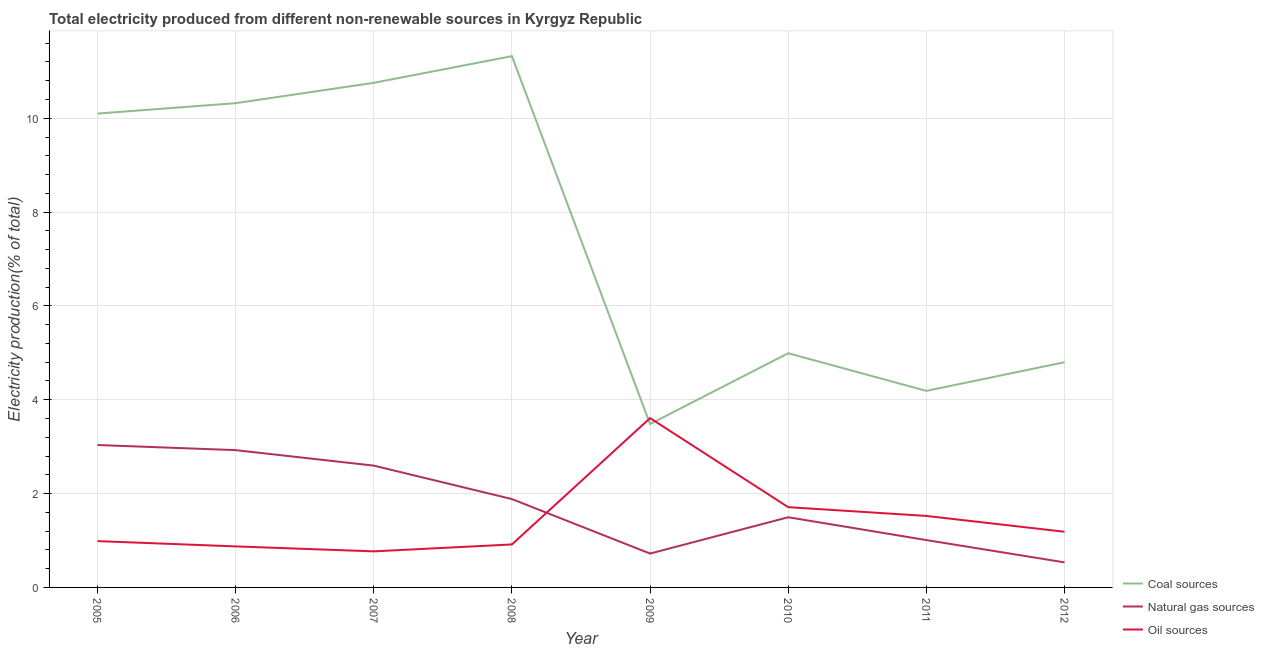Does the line corresponding to percentage of electricity produced by coal intersect with the line corresponding to percentage of electricity produced by natural gas?
Your answer should be compact. No. What is the percentage of electricity produced by natural gas in 2009?
Your answer should be compact. 0.72. Across all years, what is the maximum percentage of electricity produced by oil sources?
Ensure brevity in your answer.  3.61. Across all years, what is the minimum percentage of electricity produced by oil sources?
Offer a terse response. 0.77. What is the total percentage of electricity produced by coal in the graph?
Provide a short and direct response. 59.96. What is the difference between the percentage of electricity produced by oil sources in 2010 and that in 2011?
Keep it short and to the point. 0.19. What is the difference between the percentage of electricity produced by oil sources in 2008 and the percentage of electricity produced by natural gas in 2006?
Provide a succinct answer. -2.01. What is the average percentage of electricity produced by oil sources per year?
Make the answer very short. 1.45. In the year 2010, what is the difference between the percentage of electricity produced by oil sources and percentage of electricity produced by natural gas?
Offer a terse response. 0.21. In how many years, is the percentage of electricity produced by oil sources greater than 7.6 %?
Offer a terse response. 0. What is the ratio of the percentage of electricity produced by natural gas in 2005 to that in 2011?
Ensure brevity in your answer.  3.01. Is the difference between the percentage of electricity produced by natural gas in 2010 and 2011 greater than the difference between the percentage of electricity produced by coal in 2010 and 2011?
Ensure brevity in your answer.  No. What is the difference between the highest and the second highest percentage of electricity produced by oil sources?
Your response must be concise. 1.9. What is the difference between the highest and the lowest percentage of electricity produced by natural gas?
Provide a short and direct response. 2.5. Is the sum of the percentage of electricity produced by oil sources in 2005 and 2007 greater than the maximum percentage of electricity produced by natural gas across all years?
Your response must be concise. No. Does the percentage of electricity produced by oil sources monotonically increase over the years?
Keep it short and to the point. No. What is the difference between two consecutive major ticks on the Y-axis?
Your answer should be very brief. 2. Are the values on the major ticks of Y-axis written in scientific E-notation?
Your response must be concise. No. Does the graph contain grids?
Offer a terse response. Yes. Where does the legend appear in the graph?
Offer a terse response. Bottom right. How many legend labels are there?
Ensure brevity in your answer.  3. How are the legend labels stacked?
Offer a terse response. Vertical. What is the title of the graph?
Offer a very short reply. Total electricity produced from different non-renewable sources in Kyrgyz Republic. Does "Negligence towards kids" appear as one of the legend labels in the graph?
Provide a succinct answer. No. What is the label or title of the X-axis?
Offer a terse response. Year. What is the Electricity production(% of total) in Coal sources in 2005?
Ensure brevity in your answer.  10.1. What is the Electricity production(% of total) in Natural gas sources in 2005?
Your answer should be compact. 3.04. What is the Electricity production(% of total) in Oil sources in 2005?
Keep it short and to the point. 0.99. What is the Electricity production(% of total) of Coal sources in 2006?
Your response must be concise. 10.32. What is the Electricity production(% of total) in Natural gas sources in 2006?
Keep it short and to the point. 2.93. What is the Electricity production(% of total) of Oil sources in 2006?
Provide a succinct answer. 0.87. What is the Electricity production(% of total) of Coal sources in 2007?
Your answer should be compact. 10.76. What is the Electricity production(% of total) in Natural gas sources in 2007?
Give a very brief answer. 2.6. What is the Electricity production(% of total) of Oil sources in 2007?
Give a very brief answer. 0.77. What is the Electricity production(% of total) of Coal sources in 2008?
Provide a short and direct response. 11.32. What is the Electricity production(% of total) of Natural gas sources in 2008?
Give a very brief answer. 1.88. What is the Electricity production(% of total) of Oil sources in 2008?
Keep it short and to the point. 0.92. What is the Electricity production(% of total) of Coal sources in 2009?
Provide a short and direct response. 3.48. What is the Electricity production(% of total) of Natural gas sources in 2009?
Provide a succinct answer. 0.72. What is the Electricity production(% of total) of Oil sources in 2009?
Provide a succinct answer. 3.61. What is the Electricity production(% of total) in Coal sources in 2010?
Provide a short and direct response. 4.99. What is the Electricity production(% of total) in Natural gas sources in 2010?
Your answer should be compact. 1.5. What is the Electricity production(% of total) of Oil sources in 2010?
Ensure brevity in your answer.  1.71. What is the Electricity production(% of total) of Coal sources in 2011?
Your response must be concise. 4.19. What is the Electricity production(% of total) in Natural gas sources in 2011?
Give a very brief answer. 1.01. What is the Electricity production(% of total) in Oil sources in 2011?
Your answer should be very brief. 1.52. What is the Electricity production(% of total) of Coal sources in 2012?
Provide a succinct answer. 4.8. What is the Electricity production(% of total) in Natural gas sources in 2012?
Make the answer very short. 0.53. What is the Electricity production(% of total) in Oil sources in 2012?
Ensure brevity in your answer.  1.19. Across all years, what is the maximum Electricity production(% of total) in Coal sources?
Give a very brief answer. 11.32. Across all years, what is the maximum Electricity production(% of total) of Natural gas sources?
Your answer should be compact. 3.04. Across all years, what is the maximum Electricity production(% of total) in Oil sources?
Your response must be concise. 3.61. Across all years, what is the minimum Electricity production(% of total) of Coal sources?
Your response must be concise. 3.48. Across all years, what is the minimum Electricity production(% of total) of Natural gas sources?
Keep it short and to the point. 0.53. Across all years, what is the minimum Electricity production(% of total) of Oil sources?
Offer a very short reply. 0.77. What is the total Electricity production(% of total) in Coal sources in the graph?
Ensure brevity in your answer.  59.96. What is the total Electricity production(% of total) of Natural gas sources in the graph?
Give a very brief answer. 14.2. What is the total Electricity production(% of total) in Oil sources in the graph?
Offer a terse response. 11.58. What is the difference between the Electricity production(% of total) of Coal sources in 2005 and that in 2006?
Ensure brevity in your answer.  -0.22. What is the difference between the Electricity production(% of total) of Natural gas sources in 2005 and that in 2006?
Provide a succinct answer. 0.11. What is the difference between the Electricity production(% of total) in Oil sources in 2005 and that in 2006?
Keep it short and to the point. 0.11. What is the difference between the Electricity production(% of total) in Coal sources in 2005 and that in 2007?
Ensure brevity in your answer.  -0.66. What is the difference between the Electricity production(% of total) of Natural gas sources in 2005 and that in 2007?
Provide a short and direct response. 0.44. What is the difference between the Electricity production(% of total) in Oil sources in 2005 and that in 2007?
Make the answer very short. 0.22. What is the difference between the Electricity production(% of total) in Coal sources in 2005 and that in 2008?
Your answer should be very brief. -1.22. What is the difference between the Electricity production(% of total) of Natural gas sources in 2005 and that in 2008?
Provide a succinct answer. 1.15. What is the difference between the Electricity production(% of total) in Oil sources in 2005 and that in 2008?
Your answer should be very brief. 0.07. What is the difference between the Electricity production(% of total) of Coal sources in 2005 and that in 2009?
Your answer should be compact. 6.62. What is the difference between the Electricity production(% of total) of Natural gas sources in 2005 and that in 2009?
Make the answer very short. 2.31. What is the difference between the Electricity production(% of total) of Oil sources in 2005 and that in 2009?
Keep it short and to the point. -2.62. What is the difference between the Electricity production(% of total) in Coal sources in 2005 and that in 2010?
Keep it short and to the point. 5.11. What is the difference between the Electricity production(% of total) in Natural gas sources in 2005 and that in 2010?
Provide a succinct answer. 1.54. What is the difference between the Electricity production(% of total) of Oil sources in 2005 and that in 2010?
Your answer should be very brief. -0.72. What is the difference between the Electricity production(% of total) of Coal sources in 2005 and that in 2011?
Provide a succinct answer. 5.91. What is the difference between the Electricity production(% of total) of Natural gas sources in 2005 and that in 2011?
Make the answer very short. 2.03. What is the difference between the Electricity production(% of total) of Oil sources in 2005 and that in 2011?
Your answer should be very brief. -0.54. What is the difference between the Electricity production(% of total) in Coal sources in 2005 and that in 2012?
Offer a terse response. 5.3. What is the difference between the Electricity production(% of total) in Natural gas sources in 2005 and that in 2012?
Offer a very short reply. 2.5. What is the difference between the Electricity production(% of total) of Oil sources in 2005 and that in 2012?
Offer a terse response. -0.2. What is the difference between the Electricity production(% of total) in Coal sources in 2006 and that in 2007?
Your response must be concise. -0.43. What is the difference between the Electricity production(% of total) in Natural gas sources in 2006 and that in 2007?
Your answer should be compact. 0.33. What is the difference between the Electricity production(% of total) of Oil sources in 2006 and that in 2007?
Give a very brief answer. 0.11. What is the difference between the Electricity production(% of total) in Coal sources in 2006 and that in 2008?
Give a very brief answer. -1. What is the difference between the Electricity production(% of total) of Natural gas sources in 2006 and that in 2008?
Provide a succinct answer. 1.04. What is the difference between the Electricity production(% of total) in Oil sources in 2006 and that in 2008?
Keep it short and to the point. -0.04. What is the difference between the Electricity production(% of total) of Coal sources in 2006 and that in 2009?
Your answer should be very brief. 6.84. What is the difference between the Electricity production(% of total) in Natural gas sources in 2006 and that in 2009?
Make the answer very short. 2.2. What is the difference between the Electricity production(% of total) in Oil sources in 2006 and that in 2009?
Provide a short and direct response. -2.73. What is the difference between the Electricity production(% of total) in Coal sources in 2006 and that in 2010?
Provide a succinct answer. 5.33. What is the difference between the Electricity production(% of total) in Natural gas sources in 2006 and that in 2010?
Provide a short and direct response. 1.43. What is the difference between the Electricity production(% of total) of Oil sources in 2006 and that in 2010?
Provide a short and direct response. -0.84. What is the difference between the Electricity production(% of total) in Coal sources in 2006 and that in 2011?
Offer a terse response. 6.13. What is the difference between the Electricity production(% of total) in Natural gas sources in 2006 and that in 2011?
Give a very brief answer. 1.92. What is the difference between the Electricity production(% of total) of Oil sources in 2006 and that in 2011?
Make the answer very short. -0.65. What is the difference between the Electricity production(% of total) of Coal sources in 2006 and that in 2012?
Your answer should be compact. 5.52. What is the difference between the Electricity production(% of total) of Natural gas sources in 2006 and that in 2012?
Provide a short and direct response. 2.39. What is the difference between the Electricity production(% of total) in Oil sources in 2006 and that in 2012?
Your answer should be very brief. -0.31. What is the difference between the Electricity production(% of total) in Coal sources in 2007 and that in 2008?
Your response must be concise. -0.57. What is the difference between the Electricity production(% of total) of Natural gas sources in 2007 and that in 2008?
Give a very brief answer. 0.71. What is the difference between the Electricity production(% of total) of Oil sources in 2007 and that in 2008?
Your answer should be compact. -0.15. What is the difference between the Electricity production(% of total) in Coal sources in 2007 and that in 2009?
Provide a succinct answer. 7.27. What is the difference between the Electricity production(% of total) of Natural gas sources in 2007 and that in 2009?
Keep it short and to the point. 1.87. What is the difference between the Electricity production(% of total) in Oil sources in 2007 and that in 2009?
Provide a succinct answer. -2.84. What is the difference between the Electricity production(% of total) in Coal sources in 2007 and that in 2010?
Provide a short and direct response. 5.76. What is the difference between the Electricity production(% of total) of Natural gas sources in 2007 and that in 2010?
Give a very brief answer. 1.1. What is the difference between the Electricity production(% of total) in Oil sources in 2007 and that in 2010?
Your answer should be compact. -0.94. What is the difference between the Electricity production(% of total) in Coal sources in 2007 and that in 2011?
Keep it short and to the point. 6.57. What is the difference between the Electricity production(% of total) in Natural gas sources in 2007 and that in 2011?
Ensure brevity in your answer.  1.59. What is the difference between the Electricity production(% of total) in Oil sources in 2007 and that in 2011?
Your answer should be very brief. -0.76. What is the difference between the Electricity production(% of total) of Coal sources in 2007 and that in 2012?
Your answer should be very brief. 5.96. What is the difference between the Electricity production(% of total) in Natural gas sources in 2007 and that in 2012?
Offer a terse response. 2.06. What is the difference between the Electricity production(% of total) of Oil sources in 2007 and that in 2012?
Give a very brief answer. -0.42. What is the difference between the Electricity production(% of total) in Coal sources in 2008 and that in 2009?
Make the answer very short. 7.84. What is the difference between the Electricity production(% of total) of Natural gas sources in 2008 and that in 2009?
Your answer should be compact. 1.16. What is the difference between the Electricity production(% of total) in Oil sources in 2008 and that in 2009?
Your answer should be compact. -2.69. What is the difference between the Electricity production(% of total) in Coal sources in 2008 and that in 2010?
Give a very brief answer. 6.33. What is the difference between the Electricity production(% of total) in Natural gas sources in 2008 and that in 2010?
Provide a succinct answer. 0.39. What is the difference between the Electricity production(% of total) in Oil sources in 2008 and that in 2010?
Offer a very short reply. -0.79. What is the difference between the Electricity production(% of total) in Coal sources in 2008 and that in 2011?
Keep it short and to the point. 7.13. What is the difference between the Electricity production(% of total) in Natural gas sources in 2008 and that in 2011?
Your answer should be compact. 0.87. What is the difference between the Electricity production(% of total) of Oil sources in 2008 and that in 2011?
Provide a short and direct response. -0.61. What is the difference between the Electricity production(% of total) of Coal sources in 2008 and that in 2012?
Make the answer very short. 6.52. What is the difference between the Electricity production(% of total) of Natural gas sources in 2008 and that in 2012?
Provide a succinct answer. 1.35. What is the difference between the Electricity production(% of total) of Oil sources in 2008 and that in 2012?
Make the answer very short. -0.27. What is the difference between the Electricity production(% of total) in Coal sources in 2009 and that in 2010?
Ensure brevity in your answer.  -1.51. What is the difference between the Electricity production(% of total) of Natural gas sources in 2009 and that in 2010?
Your answer should be very brief. -0.77. What is the difference between the Electricity production(% of total) of Oil sources in 2009 and that in 2010?
Offer a terse response. 1.9. What is the difference between the Electricity production(% of total) of Coal sources in 2009 and that in 2011?
Provide a short and direct response. -0.71. What is the difference between the Electricity production(% of total) of Natural gas sources in 2009 and that in 2011?
Provide a succinct answer. -0.29. What is the difference between the Electricity production(% of total) in Oil sources in 2009 and that in 2011?
Make the answer very short. 2.09. What is the difference between the Electricity production(% of total) in Coal sources in 2009 and that in 2012?
Provide a succinct answer. -1.32. What is the difference between the Electricity production(% of total) of Natural gas sources in 2009 and that in 2012?
Offer a terse response. 0.19. What is the difference between the Electricity production(% of total) in Oil sources in 2009 and that in 2012?
Your answer should be compact. 2.42. What is the difference between the Electricity production(% of total) in Coal sources in 2010 and that in 2011?
Ensure brevity in your answer.  0.8. What is the difference between the Electricity production(% of total) of Natural gas sources in 2010 and that in 2011?
Provide a succinct answer. 0.49. What is the difference between the Electricity production(% of total) of Oil sources in 2010 and that in 2011?
Offer a terse response. 0.19. What is the difference between the Electricity production(% of total) of Coal sources in 2010 and that in 2012?
Ensure brevity in your answer.  0.19. What is the difference between the Electricity production(% of total) of Natural gas sources in 2010 and that in 2012?
Provide a succinct answer. 0.96. What is the difference between the Electricity production(% of total) of Oil sources in 2010 and that in 2012?
Make the answer very short. 0.52. What is the difference between the Electricity production(% of total) of Coal sources in 2011 and that in 2012?
Ensure brevity in your answer.  -0.61. What is the difference between the Electricity production(% of total) in Natural gas sources in 2011 and that in 2012?
Your answer should be compact. 0.48. What is the difference between the Electricity production(% of total) of Oil sources in 2011 and that in 2012?
Make the answer very short. 0.34. What is the difference between the Electricity production(% of total) of Coal sources in 2005 and the Electricity production(% of total) of Natural gas sources in 2006?
Ensure brevity in your answer.  7.17. What is the difference between the Electricity production(% of total) of Coal sources in 2005 and the Electricity production(% of total) of Oil sources in 2006?
Your answer should be very brief. 9.23. What is the difference between the Electricity production(% of total) of Natural gas sources in 2005 and the Electricity production(% of total) of Oil sources in 2006?
Give a very brief answer. 2.16. What is the difference between the Electricity production(% of total) in Coal sources in 2005 and the Electricity production(% of total) in Natural gas sources in 2007?
Offer a terse response. 7.5. What is the difference between the Electricity production(% of total) of Coal sources in 2005 and the Electricity production(% of total) of Oil sources in 2007?
Give a very brief answer. 9.33. What is the difference between the Electricity production(% of total) of Natural gas sources in 2005 and the Electricity production(% of total) of Oil sources in 2007?
Offer a terse response. 2.27. What is the difference between the Electricity production(% of total) of Coal sources in 2005 and the Electricity production(% of total) of Natural gas sources in 2008?
Your response must be concise. 8.22. What is the difference between the Electricity production(% of total) in Coal sources in 2005 and the Electricity production(% of total) in Oil sources in 2008?
Make the answer very short. 9.18. What is the difference between the Electricity production(% of total) of Natural gas sources in 2005 and the Electricity production(% of total) of Oil sources in 2008?
Your answer should be compact. 2.12. What is the difference between the Electricity production(% of total) in Coal sources in 2005 and the Electricity production(% of total) in Natural gas sources in 2009?
Provide a short and direct response. 9.38. What is the difference between the Electricity production(% of total) in Coal sources in 2005 and the Electricity production(% of total) in Oil sources in 2009?
Give a very brief answer. 6.49. What is the difference between the Electricity production(% of total) of Natural gas sources in 2005 and the Electricity production(% of total) of Oil sources in 2009?
Give a very brief answer. -0.57. What is the difference between the Electricity production(% of total) in Coal sources in 2005 and the Electricity production(% of total) in Natural gas sources in 2010?
Your answer should be very brief. 8.6. What is the difference between the Electricity production(% of total) of Coal sources in 2005 and the Electricity production(% of total) of Oil sources in 2010?
Provide a succinct answer. 8.39. What is the difference between the Electricity production(% of total) in Natural gas sources in 2005 and the Electricity production(% of total) in Oil sources in 2010?
Give a very brief answer. 1.32. What is the difference between the Electricity production(% of total) of Coal sources in 2005 and the Electricity production(% of total) of Natural gas sources in 2011?
Your response must be concise. 9.09. What is the difference between the Electricity production(% of total) in Coal sources in 2005 and the Electricity production(% of total) in Oil sources in 2011?
Provide a short and direct response. 8.58. What is the difference between the Electricity production(% of total) in Natural gas sources in 2005 and the Electricity production(% of total) in Oil sources in 2011?
Make the answer very short. 1.51. What is the difference between the Electricity production(% of total) in Coal sources in 2005 and the Electricity production(% of total) in Natural gas sources in 2012?
Your answer should be compact. 9.57. What is the difference between the Electricity production(% of total) of Coal sources in 2005 and the Electricity production(% of total) of Oil sources in 2012?
Your response must be concise. 8.91. What is the difference between the Electricity production(% of total) of Natural gas sources in 2005 and the Electricity production(% of total) of Oil sources in 2012?
Provide a short and direct response. 1.85. What is the difference between the Electricity production(% of total) in Coal sources in 2006 and the Electricity production(% of total) in Natural gas sources in 2007?
Your answer should be compact. 7.73. What is the difference between the Electricity production(% of total) of Coal sources in 2006 and the Electricity production(% of total) of Oil sources in 2007?
Your response must be concise. 9.55. What is the difference between the Electricity production(% of total) in Natural gas sources in 2006 and the Electricity production(% of total) in Oil sources in 2007?
Give a very brief answer. 2.16. What is the difference between the Electricity production(% of total) of Coal sources in 2006 and the Electricity production(% of total) of Natural gas sources in 2008?
Provide a succinct answer. 8.44. What is the difference between the Electricity production(% of total) in Coal sources in 2006 and the Electricity production(% of total) in Oil sources in 2008?
Provide a short and direct response. 9.41. What is the difference between the Electricity production(% of total) in Natural gas sources in 2006 and the Electricity production(% of total) in Oil sources in 2008?
Provide a short and direct response. 2.01. What is the difference between the Electricity production(% of total) of Coal sources in 2006 and the Electricity production(% of total) of Natural gas sources in 2009?
Ensure brevity in your answer.  9.6. What is the difference between the Electricity production(% of total) of Coal sources in 2006 and the Electricity production(% of total) of Oil sources in 2009?
Ensure brevity in your answer.  6.71. What is the difference between the Electricity production(% of total) of Natural gas sources in 2006 and the Electricity production(% of total) of Oil sources in 2009?
Your answer should be compact. -0.68. What is the difference between the Electricity production(% of total) of Coal sources in 2006 and the Electricity production(% of total) of Natural gas sources in 2010?
Ensure brevity in your answer.  8.83. What is the difference between the Electricity production(% of total) in Coal sources in 2006 and the Electricity production(% of total) in Oil sources in 2010?
Ensure brevity in your answer.  8.61. What is the difference between the Electricity production(% of total) of Natural gas sources in 2006 and the Electricity production(% of total) of Oil sources in 2010?
Make the answer very short. 1.22. What is the difference between the Electricity production(% of total) of Coal sources in 2006 and the Electricity production(% of total) of Natural gas sources in 2011?
Give a very brief answer. 9.31. What is the difference between the Electricity production(% of total) in Coal sources in 2006 and the Electricity production(% of total) in Oil sources in 2011?
Keep it short and to the point. 8.8. What is the difference between the Electricity production(% of total) in Natural gas sources in 2006 and the Electricity production(% of total) in Oil sources in 2011?
Make the answer very short. 1.4. What is the difference between the Electricity production(% of total) in Coal sources in 2006 and the Electricity production(% of total) in Natural gas sources in 2012?
Keep it short and to the point. 9.79. What is the difference between the Electricity production(% of total) in Coal sources in 2006 and the Electricity production(% of total) in Oil sources in 2012?
Offer a very short reply. 9.13. What is the difference between the Electricity production(% of total) in Natural gas sources in 2006 and the Electricity production(% of total) in Oil sources in 2012?
Give a very brief answer. 1.74. What is the difference between the Electricity production(% of total) in Coal sources in 2007 and the Electricity production(% of total) in Natural gas sources in 2008?
Provide a short and direct response. 8.87. What is the difference between the Electricity production(% of total) in Coal sources in 2007 and the Electricity production(% of total) in Oil sources in 2008?
Your response must be concise. 9.84. What is the difference between the Electricity production(% of total) in Natural gas sources in 2007 and the Electricity production(% of total) in Oil sources in 2008?
Provide a short and direct response. 1.68. What is the difference between the Electricity production(% of total) of Coal sources in 2007 and the Electricity production(% of total) of Natural gas sources in 2009?
Your answer should be very brief. 10.03. What is the difference between the Electricity production(% of total) of Coal sources in 2007 and the Electricity production(% of total) of Oil sources in 2009?
Your answer should be very brief. 7.15. What is the difference between the Electricity production(% of total) of Natural gas sources in 2007 and the Electricity production(% of total) of Oil sources in 2009?
Your answer should be very brief. -1.01. What is the difference between the Electricity production(% of total) in Coal sources in 2007 and the Electricity production(% of total) in Natural gas sources in 2010?
Your response must be concise. 9.26. What is the difference between the Electricity production(% of total) of Coal sources in 2007 and the Electricity production(% of total) of Oil sources in 2010?
Make the answer very short. 9.04. What is the difference between the Electricity production(% of total) of Natural gas sources in 2007 and the Electricity production(% of total) of Oil sources in 2010?
Ensure brevity in your answer.  0.89. What is the difference between the Electricity production(% of total) of Coal sources in 2007 and the Electricity production(% of total) of Natural gas sources in 2011?
Your response must be concise. 9.75. What is the difference between the Electricity production(% of total) in Coal sources in 2007 and the Electricity production(% of total) in Oil sources in 2011?
Ensure brevity in your answer.  9.23. What is the difference between the Electricity production(% of total) of Natural gas sources in 2007 and the Electricity production(% of total) of Oil sources in 2011?
Offer a very short reply. 1.07. What is the difference between the Electricity production(% of total) of Coal sources in 2007 and the Electricity production(% of total) of Natural gas sources in 2012?
Offer a very short reply. 10.22. What is the difference between the Electricity production(% of total) in Coal sources in 2007 and the Electricity production(% of total) in Oil sources in 2012?
Provide a short and direct response. 9.57. What is the difference between the Electricity production(% of total) of Natural gas sources in 2007 and the Electricity production(% of total) of Oil sources in 2012?
Offer a very short reply. 1.41. What is the difference between the Electricity production(% of total) of Coal sources in 2008 and the Electricity production(% of total) of Natural gas sources in 2009?
Ensure brevity in your answer.  10.6. What is the difference between the Electricity production(% of total) in Coal sources in 2008 and the Electricity production(% of total) in Oil sources in 2009?
Your answer should be compact. 7.71. What is the difference between the Electricity production(% of total) of Natural gas sources in 2008 and the Electricity production(% of total) of Oil sources in 2009?
Make the answer very short. -1.73. What is the difference between the Electricity production(% of total) in Coal sources in 2008 and the Electricity production(% of total) in Natural gas sources in 2010?
Give a very brief answer. 9.83. What is the difference between the Electricity production(% of total) of Coal sources in 2008 and the Electricity production(% of total) of Oil sources in 2010?
Offer a very short reply. 9.61. What is the difference between the Electricity production(% of total) in Natural gas sources in 2008 and the Electricity production(% of total) in Oil sources in 2010?
Offer a terse response. 0.17. What is the difference between the Electricity production(% of total) in Coal sources in 2008 and the Electricity production(% of total) in Natural gas sources in 2011?
Ensure brevity in your answer.  10.31. What is the difference between the Electricity production(% of total) in Coal sources in 2008 and the Electricity production(% of total) in Oil sources in 2011?
Keep it short and to the point. 9.8. What is the difference between the Electricity production(% of total) in Natural gas sources in 2008 and the Electricity production(% of total) in Oil sources in 2011?
Offer a very short reply. 0.36. What is the difference between the Electricity production(% of total) in Coal sources in 2008 and the Electricity production(% of total) in Natural gas sources in 2012?
Your answer should be compact. 10.79. What is the difference between the Electricity production(% of total) of Coal sources in 2008 and the Electricity production(% of total) of Oil sources in 2012?
Provide a short and direct response. 10.14. What is the difference between the Electricity production(% of total) of Natural gas sources in 2008 and the Electricity production(% of total) of Oil sources in 2012?
Your answer should be very brief. 0.7. What is the difference between the Electricity production(% of total) in Coal sources in 2009 and the Electricity production(% of total) in Natural gas sources in 2010?
Ensure brevity in your answer.  1.99. What is the difference between the Electricity production(% of total) in Coal sources in 2009 and the Electricity production(% of total) in Oil sources in 2010?
Keep it short and to the point. 1.77. What is the difference between the Electricity production(% of total) of Natural gas sources in 2009 and the Electricity production(% of total) of Oil sources in 2010?
Your answer should be very brief. -0.99. What is the difference between the Electricity production(% of total) of Coal sources in 2009 and the Electricity production(% of total) of Natural gas sources in 2011?
Provide a succinct answer. 2.47. What is the difference between the Electricity production(% of total) in Coal sources in 2009 and the Electricity production(% of total) in Oil sources in 2011?
Provide a short and direct response. 1.96. What is the difference between the Electricity production(% of total) in Natural gas sources in 2009 and the Electricity production(% of total) in Oil sources in 2011?
Give a very brief answer. -0.8. What is the difference between the Electricity production(% of total) in Coal sources in 2009 and the Electricity production(% of total) in Natural gas sources in 2012?
Offer a very short reply. 2.95. What is the difference between the Electricity production(% of total) of Coal sources in 2009 and the Electricity production(% of total) of Oil sources in 2012?
Give a very brief answer. 2.3. What is the difference between the Electricity production(% of total) in Natural gas sources in 2009 and the Electricity production(% of total) in Oil sources in 2012?
Make the answer very short. -0.46. What is the difference between the Electricity production(% of total) of Coal sources in 2010 and the Electricity production(% of total) of Natural gas sources in 2011?
Your answer should be compact. 3.98. What is the difference between the Electricity production(% of total) in Coal sources in 2010 and the Electricity production(% of total) in Oil sources in 2011?
Offer a very short reply. 3.47. What is the difference between the Electricity production(% of total) in Natural gas sources in 2010 and the Electricity production(% of total) in Oil sources in 2011?
Provide a short and direct response. -0.03. What is the difference between the Electricity production(% of total) of Coal sources in 2010 and the Electricity production(% of total) of Natural gas sources in 2012?
Offer a very short reply. 4.46. What is the difference between the Electricity production(% of total) in Coal sources in 2010 and the Electricity production(% of total) in Oil sources in 2012?
Your response must be concise. 3.81. What is the difference between the Electricity production(% of total) in Natural gas sources in 2010 and the Electricity production(% of total) in Oil sources in 2012?
Your response must be concise. 0.31. What is the difference between the Electricity production(% of total) of Coal sources in 2011 and the Electricity production(% of total) of Natural gas sources in 2012?
Offer a very short reply. 3.66. What is the difference between the Electricity production(% of total) of Coal sources in 2011 and the Electricity production(% of total) of Oil sources in 2012?
Your answer should be very brief. 3. What is the difference between the Electricity production(% of total) of Natural gas sources in 2011 and the Electricity production(% of total) of Oil sources in 2012?
Keep it short and to the point. -0.18. What is the average Electricity production(% of total) in Coal sources per year?
Keep it short and to the point. 7.5. What is the average Electricity production(% of total) of Natural gas sources per year?
Your answer should be compact. 1.78. What is the average Electricity production(% of total) in Oil sources per year?
Give a very brief answer. 1.45. In the year 2005, what is the difference between the Electricity production(% of total) in Coal sources and Electricity production(% of total) in Natural gas sources?
Your answer should be very brief. 7.06. In the year 2005, what is the difference between the Electricity production(% of total) of Coal sources and Electricity production(% of total) of Oil sources?
Offer a very short reply. 9.11. In the year 2005, what is the difference between the Electricity production(% of total) of Natural gas sources and Electricity production(% of total) of Oil sources?
Offer a terse response. 2.05. In the year 2006, what is the difference between the Electricity production(% of total) in Coal sources and Electricity production(% of total) in Natural gas sources?
Provide a short and direct response. 7.4. In the year 2006, what is the difference between the Electricity production(% of total) of Coal sources and Electricity production(% of total) of Oil sources?
Your response must be concise. 9.45. In the year 2006, what is the difference between the Electricity production(% of total) of Natural gas sources and Electricity production(% of total) of Oil sources?
Keep it short and to the point. 2.05. In the year 2007, what is the difference between the Electricity production(% of total) in Coal sources and Electricity production(% of total) in Natural gas sources?
Ensure brevity in your answer.  8.16. In the year 2007, what is the difference between the Electricity production(% of total) in Coal sources and Electricity production(% of total) in Oil sources?
Offer a terse response. 9.99. In the year 2007, what is the difference between the Electricity production(% of total) of Natural gas sources and Electricity production(% of total) of Oil sources?
Provide a short and direct response. 1.83. In the year 2008, what is the difference between the Electricity production(% of total) of Coal sources and Electricity production(% of total) of Natural gas sources?
Offer a terse response. 9.44. In the year 2008, what is the difference between the Electricity production(% of total) in Coal sources and Electricity production(% of total) in Oil sources?
Keep it short and to the point. 10.41. In the year 2009, what is the difference between the Electricity production(% of total) in Coal sources and Electricity production(% of total) in Natural gas sources?
Keep it short and to the point. 2.76. In the year 2009, what is the difference between the Electricity production(% of total) of Coal sources and Electricity production(% of total) of Oil sources?
Ensure brevity in your answer.  -0.13. In the year 2009, what is the difference between the Electricity production(% of total) of Natural gas sources and Electricity production(% of total) of Oil sources?
Ensure brevity in your answer.  -2.89. In the year 2010, what is the difference between the Electricity production(% of total) of Coal sources and Electricity production(% of total) of Natural gas sources?
Provide a short and direct response. 3.5. In the year 2010, what is the difference between the Electricity production(% of total) in Coal sources and Electricity production(% of total) in Oil sources?
Your answer should be very brief. 3.28. In the year 2010, what is the difference between the Electricity production(% of total) in Natural gas sources and Electricity production(% of total) in Oil sources?
Give a very brief answer. -0.21. In the year 2011, what is the difference between the Electricity production(% of total) in Coal sources and Electricity production(% of total) in Natural gas sources?
Give a very brief answer. 3.18. In the year 2011, what is the difference between the Electricity production(% of total) of Coal sources and Electricity production(% of total) of Oil sources?
Offer a terse response. 2.67. In the year 2011, what is the difference between the Electricity production(% of total) of Natural gas sources and Electricity production(% of total) of Oil sources?
Ensure brevity in your answer.  -0.51. In the year 2012, what is the difference between the Electricity production(% of total) in Coal sources and Electricity production(% of total) in Natural gas sources?
Give a very brief answer. 4.27. In the year 2012, what is the difference between the Electricity production(% of total) in Coal sources and Electricity production(% of total) in Oil sources?
Your response must be concise. 3.61. In the year 2012, what is the difference between the Electricity production(% of total) in Natural gas sources and Electricity production(% of total) in Oil sources?
Make the answer very short. -0.65. What is the ratio of the Electricity production(% of total) in Coal sources in 2005 to that in 2006?
Your answer should be compact. 0.98. What is the ratio of the Electricity production(% of total) of Natural gas sources in 2005 to that in 2006?
Provide a succinct answer. 1.04. What is the ratio of the Electricity production(% of total) in Oil sources in 2005 to that in 2006?
Ensure brevity in your answer.  1.13. What is the ratio of the Electricity production(% of total) in Coal sources in 2005 to that in 2007?
Keep it short and to the point. 0.94. What is the ratio of the Electricity production(% of total) in Natural gas sources in 2005 to that in 2007?
Offer a terse response. 1.17. What is the ratio of the Electricity production(% of total) in Oil sources in 2005 to that in 2007?
Provide a succinct answer. 1.28. What is the ratio of the Electricity production(% of total) in Coal sources in 2005 to that in 2008?
Provide a succinct answer. 0.89. What is the ratio of the Electricity production(% of total) in Natural gas sources in 2005 to that in 2008?
Your answer should be compact. 1.61. What is the ratio of the Electricity production(% of total) in Oil sources in 2005 to that in 2008?
Offer a very short reply. 1.08. What is the ratio of the Electricity production(% of total) in Natural gas sources in 2005 to that in 2009?
Ensure brevity in your answer.  4.21. What is the ratio of the Electricity production(% of total) in Oil sources in 2005 to that in 2009?
Offer a terse response. 0.27. What is the ratio of the Electricity production(% of total) in Coal sources in 2005 to that in 2010?
Ensure brevity in your answer.  2.02. What is the ratio of the Electricity production(% of total) of Natural gas sources in 2005 to that in 2010?
Provide a short and direct response. 2.03. What is the ratio of the Electricity production(% of total) of Oil sources in 2005 to that in 2010?
Your answer should be compact. 0.58. What is the ratio of the Electricity production(% of total) in Coal sources in 2005 to that in 2011?
Offer a terse response. 2.41. What is the ratio of the Electricity production(% of total) in Natural gas sources in 2005 to that in 2011?
Give a very brief answer. 3.01. What is the ratio of the Electricity production(% of total) in Oil sources in 2005 to that in 2011?
Your response must be concise. 0.65. What is the ratio of the Electricity production(% of total) in Coal sources in 2005 to that in 2012?
Provide a short and direct response. 2.1. What is the ratio of the Electricity production(% of total) of Natural gas sources in 2005 to that in 2012?
Make the answer very short. 5.68. What is the ratio of the Electricity production(% of total) in Oil sources in 2005 to that in 2012?
Your answer should be compact. 0.83. What is the ratio of the Electricity production(% of total) in Coal sources in 2006 to that in 2007?
Offer a very short reply. 0.96. What is the ratio of the Electricity production(% of total) in Natural gas sources in 2006 to that in 2007?
Offer a terse response. 1.13. What is the ratio of the Electricity production(% of total) in Oil sources in 2006 to that in 2007?
Keep it short and to the point. 1.14. What is the ratio of the Electricity production(% of total) in Coal sources in 2006 to that in 2008?
Offer a very short reply. 0.91. What is the ratio of the Electricity production(% of total) in Natural gas sources in 2006 to that in 2008?
Give a very brief answer. 1.55. What is the ratio of the Electricity production(% of total) of Oil sources in 2006 to that in 2008?
Provide a succinct answer. 0.95. What is the ratio of the Electricity production(% of total) of Coal sources in 2006 to that in 2009?
Offer a terse response. 2.96. What is the ratio of the Electricity production(% of total) of Natural gas sources in 2006 to that in 2009?
Your answer should be compact. 4.05. What is the ratio of the Electricity production(% of total) of Oil sources in 2006 to that in 2009?
Offer a very short reply. 0.24. What is the ratio of the Electricity production(% of total) in Coal sources in 2006 to that in 2010?
Keep it short and to the point. 2.07. What is the ratio of the Electricity production(% of total) of Natural gas sources in 2006 to that in 2010?
Your answer should be very brief. 1.96. What is the ratio of the Electricity production(% of total) of Oil sources in 2006 to that in 2010?
Your answer should be very brief. 0.51. What is the ratio of the Electricity production(% of total) of Coal sources in 2006 to that in 2011?
Keep it short and to the point. 2.46. What is the ratio of the Electricity production(% of total) in Natural gas sources in 2006 to that in 2011?
Give a very brief answer. 2.9. What is the ratio of the Electricity production(% of total) of Oil sources in 2006 to that in 2011?
Ensure brevity in your answer.  0.57. What is the ratio of the Electricity production(% of total) in Coal sources in 2006 to that in 2012?
Your response must be concise. 2.15. What is the ratio of the Electricity production(% of total) in Natural gas sources in 2006 to that in 2012?
Provide a short and direct response. 5.48. What is the ratio of the Electricity production(% of total) in Oil sources in 2006 to that in 2012?
Make the answer very short. 0.74. What is the ratio of the Electricity production(% of total) of Coal sources in 2007 to that in 2008?
Provide a short and direct response. 0.95. What is the ratio of the Electricity production(% of total) in Natural gas sources in 2007 to that in 2008?
Provide a short and direct response. 1.38. What is the ratio of the Electricity production(% of total) in Oil sources in 2007 to that in 2008?
Offer a terse response. 0.84. What is the ratio of the Electricity production(% of total) of Coal sources in 2007 to that in 2009?
Your response must be concise. 3.09. What is the ratio of the Electricity production(% of total) in Natural gas sources in 2007 to that in 2009?
Your answer should be compact. 3.6. What is the ratio of the Electricity production(% of total) of Oil sources in 2007 to that in 2009?
Provide a short and direct response. 0.21. What is the ratio of the Electricity production(% of total) of Coal sources in 2007 to that in 2010?
Offer a terse response. 2.15. What is the ratio of the Electricity production(% of total) in Natural gas sources in 2007 to that in 2010?
Make the answer very short. 1.74. What is the ratio of the Electricity production(% of total) of Oil sources in 2007 to that in 2010?
Your answer should be compact. 0.45. What is the ratio of the Electricity production(% of total) in Coal sources in 2007 to that in 2011?
Your answer should be very brief. 2.57. What is the ratio of the Electricity production(% of total) of Natural gas sources in 2007 to that in 2011?
Keep it short and to the point. 2.57. What is the ratio of the Electricity production(% of total) in Oil sources in 2007 to that in 2011?
Offer a terse response. 0.5. What is the ratio of the Electricity production(% of total) in Coal sources in 2007 to that in 2012?
Provide a succinct answer. 2.24. What is the ratio of the Electricity production(% of total) of Natural gas sources in 2007 to that in 2012?
Your response must be concise. 4.86. What is the ratio of the Electricity production(% of total) in Oil sources in 2007 to that in 2012?
Provide a succinct answer. 0.65. What is the ratio of the Electricity production(% of total) of Coal sources in 2008 to that in 2009?
Provide a succinct answer. 3.25. What is the ratio of the Electricity production(% of total) of Natural gas sources in 2008 to that in 2009?
Keep it short and to the point. 2.61. What is the ratio of the Electricity production(% of total) in Oil sources in 2008 to that in 2009?
Provide a short and direct response. 0.25. What is the ratio of the Electricity production(% of total) of Coal sources in 2008 to that in 2010?
Provide a short and direct response. 2.27. What is the ratio of the Electricity production(% of total) of Natural gas sources in 2008 to that in 2010?
Offer a terse response. 1.26. What is the ratio of the Electricity production(% of total) of Oil sources in 2008 to that in 2010?
Provide a short and direct response. 0.54. What is the ratio of the Electricity production(% of total) of Coal sources in 2008 to that in 2011?
Keep it short and to the point. 2.7. What is the ratio of the Electricity production(% of total) in Natural gas sources in 2008 to that in 2011?
Keep it short and to the point. 1.87. What is the ratio of the Electricity production(% of total) in Oil sources in 2008 to that in 2011?
Provide a succinct answer. 0.6. What is the ratio of the Electricity production(% of total) in Coal sources in 2008 to that in 2012?
Give a very brief answer. 2.36. What is the ratio of the Electricity production(% of total) in Natural gas sources in 2008 to that in 2012?
Your answer should be compact. 3.53. What is the ratio of the Electricity production(% of total) of Oil sources in 2008 to that in 2012?
Offer a very short reply. 0.77. What is the ratio of the Electricity production(% of total) in Coal sources in 2009 to that in 2010?
Offer a terse response. 0.7. What is the ratio of the Electricity production(% of total) of Natural gas sources in 2009 to that in 2010?
Your answer should be very brief. 0.48. What is the ratio of the Electricity production(% of total) in Oil sources in 2009 to that in 2010?
Your response must be concise. 2.11. What is the ratio of the Electricity production(% of total) of Coal sources in 2009 to that in 2011?
Offer a very short reply. 0.83. What is the ratio of the Electricity production(% of total) in Natural gas sources in 2009 to that in 2011?
Ensure brevity in your answer.  0.72. What is the ratio of the Electricity production(% of total) in Oil sources in 2009 to that in 2011?
Your answer should be compact. 2.37. What is the ratio of the Electricity production(% of total) in Coal sources in 2009 to that in 2012?
Your answer should be compact. 0.73. What is the ratio of the Electricity production(% of total) of Natural gas sources in 2009 to that in 2012?
Offer a terse response. 1.35. What is the ratio of the Electricity production(% of total) in Oil sources in 2009 to that in 2012?
Keep it short and to the point. 3.04. What is the ratio of the Electricity production(% of total) of Coal sources in 2010 to that in 2011?
Provide a short and direct response. 1.19. What is the ratio of the Electricity production(% of total) in Natural gas sources in 2010 to that in 2011?
Ensure brevity in your answer.  1.48. What is the ratio of the Electricity production(% of total) in Oil sources in 2010 to that in 2011?
Your answer should be compact. 1.12. What is the ratio of the Electricity production(% of total) in Natural gas sources in 2010 to that in 2012?
Your answer should be compact. 2.8. What is the ratio of the Electricity production(% of total) in Oil sources in 2010 to that in 2012?
Give a very brief answer. 1.44. What is the ratio of the Electricity production(% of total) of Coal sources in 2011 to that in 2012?
Make the answer very short. 0.87. What is the ratio of the Electricity production(% of total) of Natural gas sources in 2011 to that in 2012?
Your answer should be very brief. 1.89. What is the ratio of the Electricity production(% of total) of Oil sources in 2011 to that in 2012?
Give a very brief answer. 1.28. What is the difference between the highest and the second highest Electricity production(% of total) in Coal sources?
Keep it short and to the point. 0.57. What is the difference between the highest and the second highest Electricity production(% of total) of Natural gas sources?
Give a very brief answer. 0.11. What is the difference between the highest and the second highest Electricity production(% of total) in Oil sources?
Offer a very short reply. 1.9. What is the difference between the highest and the lowest Electricity production(% of total) of Coal sources?
Ensure brevity in your answer.  7.84. What is the difference between the highest and the lowest Electricity production(% of total) of Natural gas sources?
Offer a terse response. 2.5. What is the difference between the highest and the lowest Electricity production(% of total) in Oil sources?
Your answer should be compact. 2.84. 